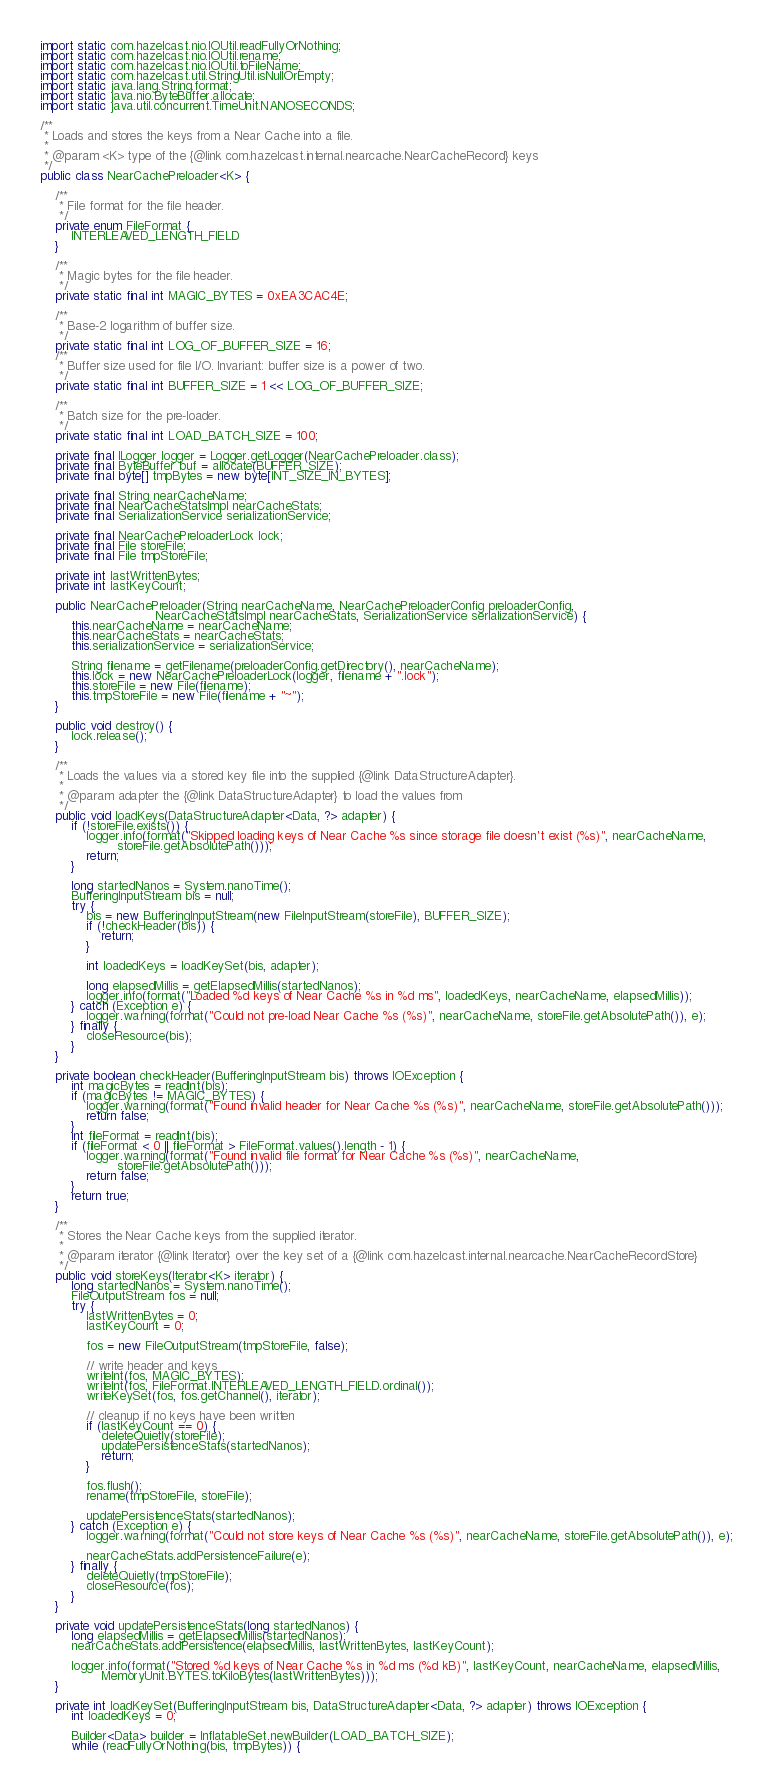<code> <loc_0><loc_0><loc_500><loc_500><_Java_>import static com.hazelcast.nio.IOUtil.readFullyOrNothing;
import static com.hazelcast.nio.IOUtil.rename;
import static com.hazelcast.nio.IOUtil.toFileName;
import static com.hazelcast.util.StringUtil.isNullOrEmpty;
import static java.lang.String.format;
import static java.nio.ByteBuffer.allocate;
import static java.util.concurrent.TimeUnit.NANOSECONDS;

/**
 * Loads and stores the keys from a Near Cache into a file.
 *
 * @param <K> type of the {@link com.hazelcast.internal.nearcache.NearCacheRecord} keys
 */
public class NearCachePreloader<K> {

    /**
     * File format for the file header.
     */
    private enum FileFormat {
        INTERLEAVED_LENGTH_FIELD
    }

    /**
     * Magic bytes for the file header.
     */
    private static final int MAGIC_BYTES = 0xEA3CAC4E;

    /**
     * Base-2 logarithm of buffer size.
     */
    private static final int LOG_OF_BUFFER_SIZE = 16;
    /**
     * Buffer size used for file I/O. Invariant: buffer size is a power of two.
     */
    private static final int BUFFER_SIZE = 1 << LOG_OF_BUFFER_SIZE;

    /**
     * Batch size for the pre-loader.
     */
    private static final int LOAD_BATCH_SIZE = 100;

    private final ILogger logger = Logger.getLogger(NearCachePreloader.class);
    private final ByteBuffer buf = allocate(BUFFER_SIZE);
    private final byte[] tmpBytes = new byte[INT_SIZE_IN_BYTES];

    private final String nearCacheName;
    private final NearCacheStatsImpl nearCacheStats;
    private final SerializationService serializationService;

    private final NearCachePreloaderLock lock;
    private final File storeFile;
    private final File tmpStoreFile;

    private int lastWrittenBytes;
    private int lastKeyCount;

    public NearCachePreloader(String nearCacheName, NearCachePreloaderConfig preloaderConfig,
                              NearCacheStatsImpl nearCacheStats, SerializationService serializationService) {
        this.nearCacheName = nearCacheName;
        this.nearCacheStats = nearCacheStats;
        this.serializationService = serializationService;

        String filename = getFilename(preloaderConfig.getDirectory(), nearCacheName);
        this.lock = new NearCachePreloaderLock(logger, filename + ".lock");
        this.storeFile = new File(filename);
        this.tmpStoreFile = new File(filename + "~");
    }

    public void destroy() {
        lock.release();
    }

    /**
     * Loads the values via a stored key file into the supplied {@link DataStructureAdapter}.
     *
     * @param adapter the {@link DataStructureAdapter} to load the values from
     */
    public void loadKeys(DataStructureAdapter<Data, ?> adapter) {
        if (!storeFile.exists()) {
            logger.info(format("Skipped loading keys of Near Cache %s since storage file doesn't exist (%s)", nearCacheName,
                    storeFile.getAbsolutePath()));
            return;
        }

        long startedNanos = System.nanoTime();
        BufferingInputStream bis = null;
        try {
            bis = new BufferingInputStream(new FileInputStream(storeFile), BUFFER_SIZE);
            if (!checkHeader(bis)) {
                return;
            }

            int loadedKeys = loadKeySet(bis, adapter);

            long elapsedMillis = getElapsedMillis(startedNanos);
            logger.info(format("Loaded %d keys of Near Cache %s in %d ms", loadedKeys, nearCacheName, elapsedMillis));
        } catch (Exception e) {
            logger.warning(format("Could not pre-load Near Cache %s (%s)", nearCacheName, storeFile.getAbsolutePath()), e);
        } finally {
            closeResource(bis);
        }
    }

    private boolean checkHeader(BufferingInputStream bis) throws IOException {
        int magicBytes = readInt(bis);
        if (magicBytes != MAGIC_BYTES) {
            logger.warning(format("Found invalid header for Near Cache %s (%s)", nearCacheName, storeFile.getAbsolutePath()));
            return false;
        }
        int fileFormat = readInt(bis);
        if (fileFormat < 0 || fileFormat > FileFormat.values().length - 1) {
            logger.warning(format("Found invalid file format for Near Cache %s (%s)", nearCacheName,
                    storeFile.getAbsolutePath()));
            return false;
        }
        return true;
    }

    /**
     * Stores the Near Cache keys from the supplied iterator.
     *
     * @param iterator {@link Iterator} over the key set of a {@link com.hazelcast.internal.nearcache.NearCacheRecordStore}
     */
    public void storeKeys(Iterator<K> iterator) {
        long startedNanos = System.nanoTime();
        FileOutputStream fos = null;
        try {
            lastWrittenBytes = 0;
            lastKeyCount = 0;

            fos = new FileOutputStream(tmpStoreFile, false);

            // write header and keys
            writeInt(fos, MAGIC_BYTES);
            writeInt(fos, FileFormat.INTERLEAVED_LENGTH_FIELD.ordinal());
            writeKeySet(fos, fos.getChannel(), iterator);

            // cleanup if no keys have been written
            if (lastKeyCount == 0) {
                deleteQuietly(storeFile);
                updatePersistenceStats(startedNanos);
                return;
            }

            fos.flush();
            rename(tmpStoreFile, storeFile);

            updatePersistenceStats(startedNanos);
        } catch (Exception e) {
            logger.warning(format("Could not store keys of Near Cache %s (%s)", nearCacheName, storeFile.getAbsolutePath()), e);

            nearCacheStats.addPersistenceFailure(e);
        } finally {
            deleteQuietly(tmpStoreFile);
            closeResource(fos);
        }
    }

    private void updatePersistenceStats(long startedNanos) {
        long elapsedMillis = getElapsedMillis(startedNanos);
        nearCacheStats.addPersistence(elapsedMillis, lastWrittenBytes, lastKeyCount);

        logger.info(format("Stored %d keys of Near Cache %s in %d ms (%d kB)", lastKeyCount, nearCacheName, elapsedMillis,
                MemoryUnit.BYTES.toKiloBytes(lastWrittenBytes)));
    }

    private int loadKeySet(BufferingInputStream bis, DataStructureAdapter<Data, ?> adapter) throws IOException {
        int loadedKeys = 0;

        Builder<Data> builder = InflatableSet.newBuilder(LOAD_BATCH_SIZE);
        while (readFullyOrNothing(bis, tmpBytes)) {</code> 